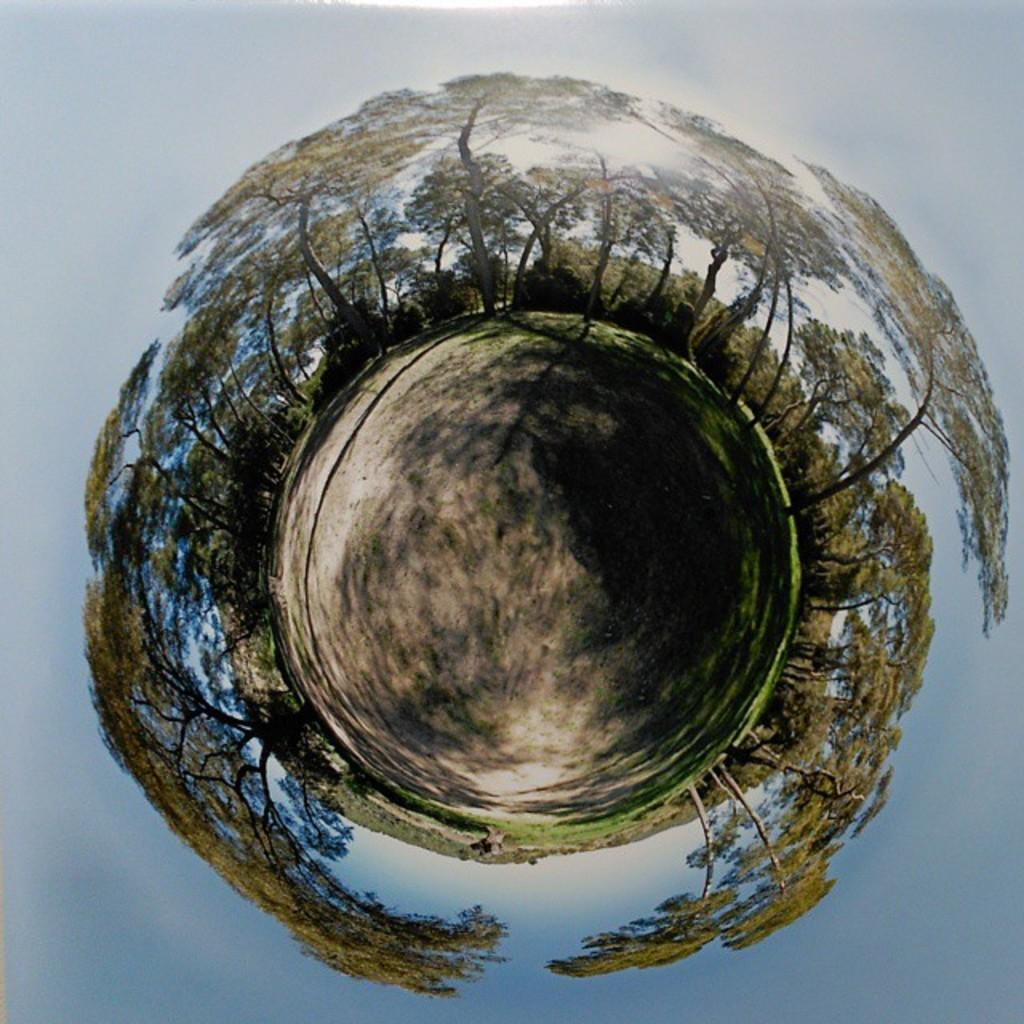What type of view is provided by the image? The image appears to be a 360-degree view. What type of vegetation can be seen in the image? There are trees in the image. What is the surface visible in the image? There is a ground visible in the image. What type of glass is used to create the force field in the image? There is no force field or glass present in the image; it features a 360-degree view of a landscape with trees and ground. 